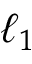Convert formula to latex. <formula><loc_0><loc_0><loc_500><loc_500>\ell _ { 1 }</formula> 